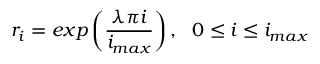Convert formula to latex. <formula><loc_0><loc_0><loc_500><loc_500>r _ { i } = e x p \left ( \frac { \lambda \pi i } { i _ { \max } } \right ) , \ \ 0 \leq i \leq i _ { \max }</formula> 